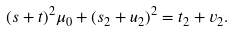<formula> <loc_0><loc_0><loc_500><loc_500>( s + t ) ^ { 2 } \mu _ { 0 } + ( s _ { 2 } + u _ { 2 } ) ^ { 2 } = t _ { 2 } + v _ { 2 } .</formula> 